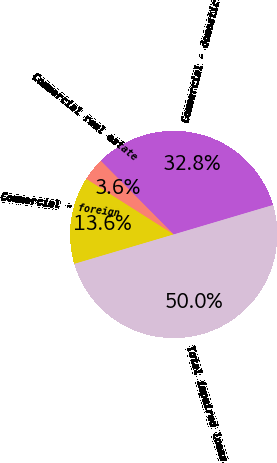Convert chart to OTSL. <chart><loc_0><loc_0><loc_500><loc_500><pie_chart><fcel>Commercial - domestic<fcel>Commercial real estate<fcel>Commercial - foreign<fcel>Total impaired loans<nl><fcel>32.83%<fcel>3.58%<fcel>13.59%<fcel>50.0%<nl></chart> 